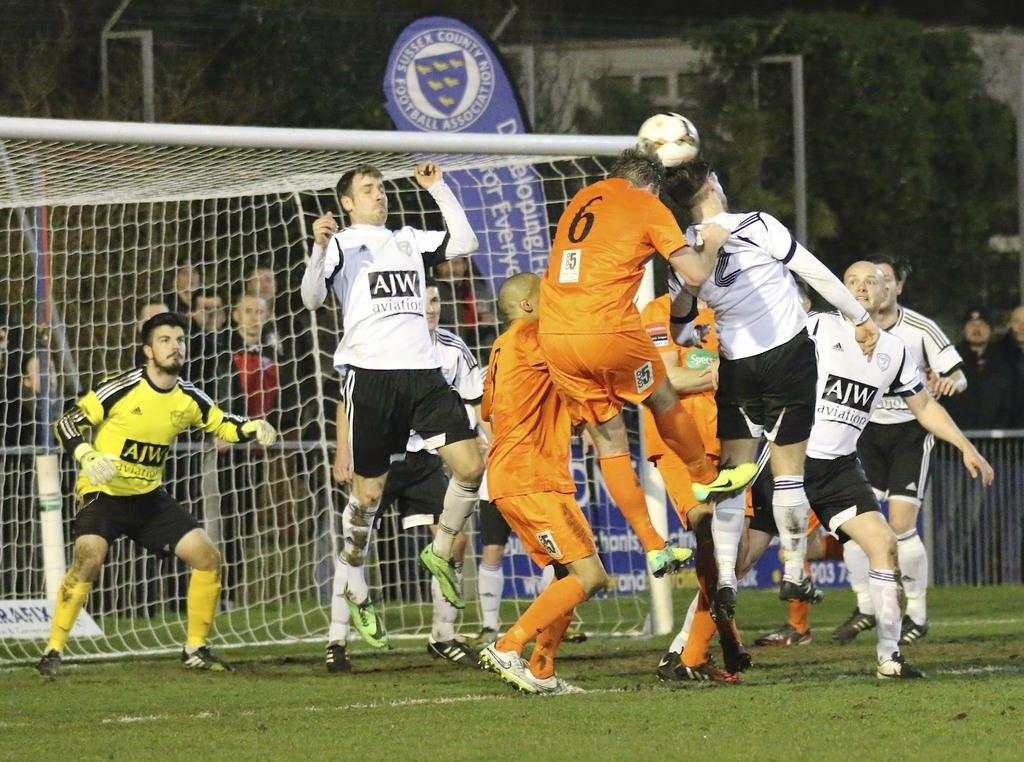What can be seen in the background of the image? There are windows and trees visible in the background. What type of signage is present in the image? There is a hoarding board in the image. What activity are the persons engaged in? The persons are playing with a ball in a playground. What safety feature is present in the playground? There is a net present in the playground. What is the rate of the soda being consumed by the persons in the image? There is no soda present in the image, so it is not possible to determine the rate of consumption. 